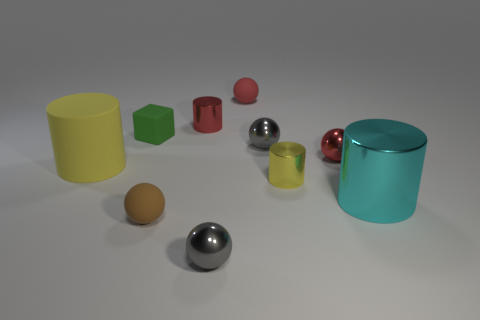Are there an equal number of large yellow things that are on the right side of the small green thing and big purple spheres?
Your answer should be very brief. Yes. Are there any other things that have the same size as the red cylinder?
Give a very brief answer. Yes. What is the shape of the other thing that is the same size as the yellow matte object?
Keep it short and to the point. Cylinder. Are there any big yellow matte things of the same shape as the large cyan metal object?
Offer a very short reply. Yes. There is a small yellow metallic cylinder right of the rubber thing that is in front of the cyan metallic object; is there a tiny gray metallic thing that is in front of it?
Offer a terse response. Yes. Are there more yellow metal things that are on the left side of the green object than large yellow matte objects that are in front of the large cyan metal cylinder?
Provide a succinct answer. No. There is a red cylinder that is the same size as the green rubber thing; what is its material?
Provide a succinct answer. Metal. How many big things are either gray balls or brown objects?
Give a very brief answer. 0. Is the tiny yellow thing the same shape as the brown rubber object?
Make the answer very short. No. How many objects are behind the small brown thing and on the right side of the large yellow thing?
Keep it short and to the point. 7. 